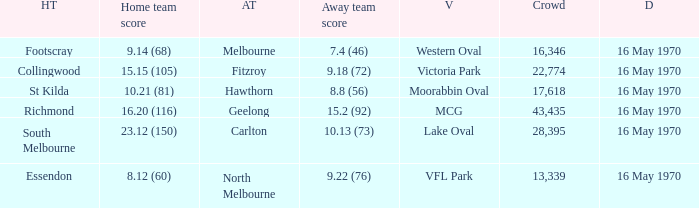Who was the away team at western oval? Melbourne. 